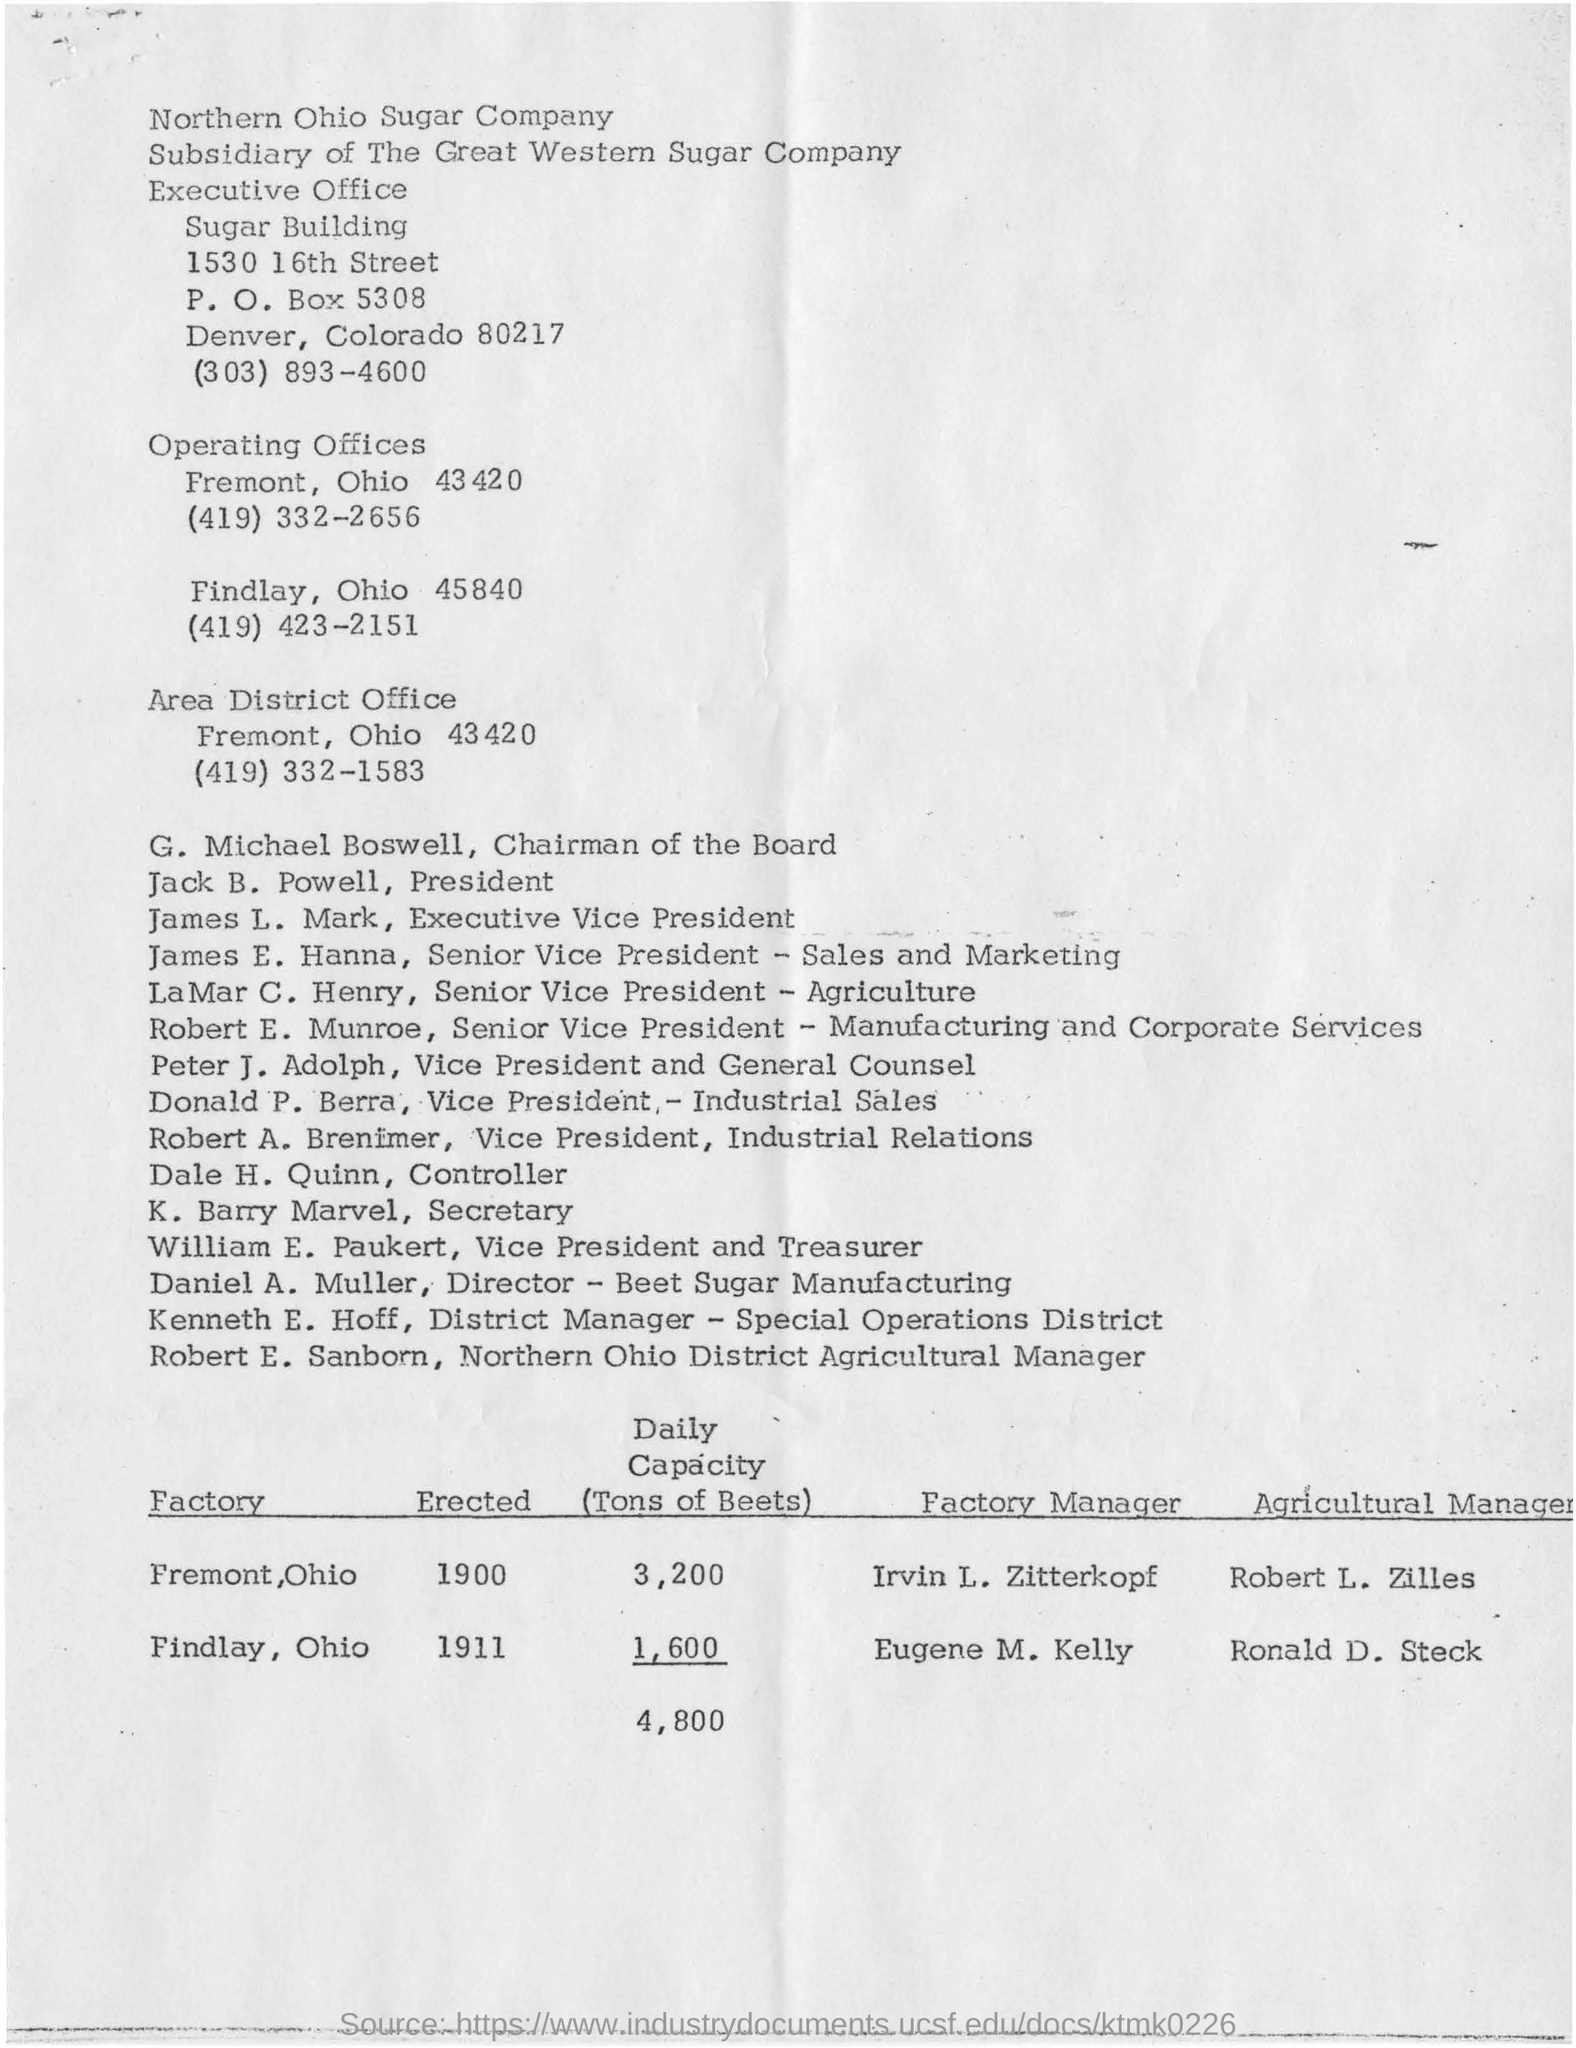what is the post box number for the location of 1530 16th street sugar building? The post box number for the Sugar Building located at 1530 16th Street is P.O. Box 5308. 